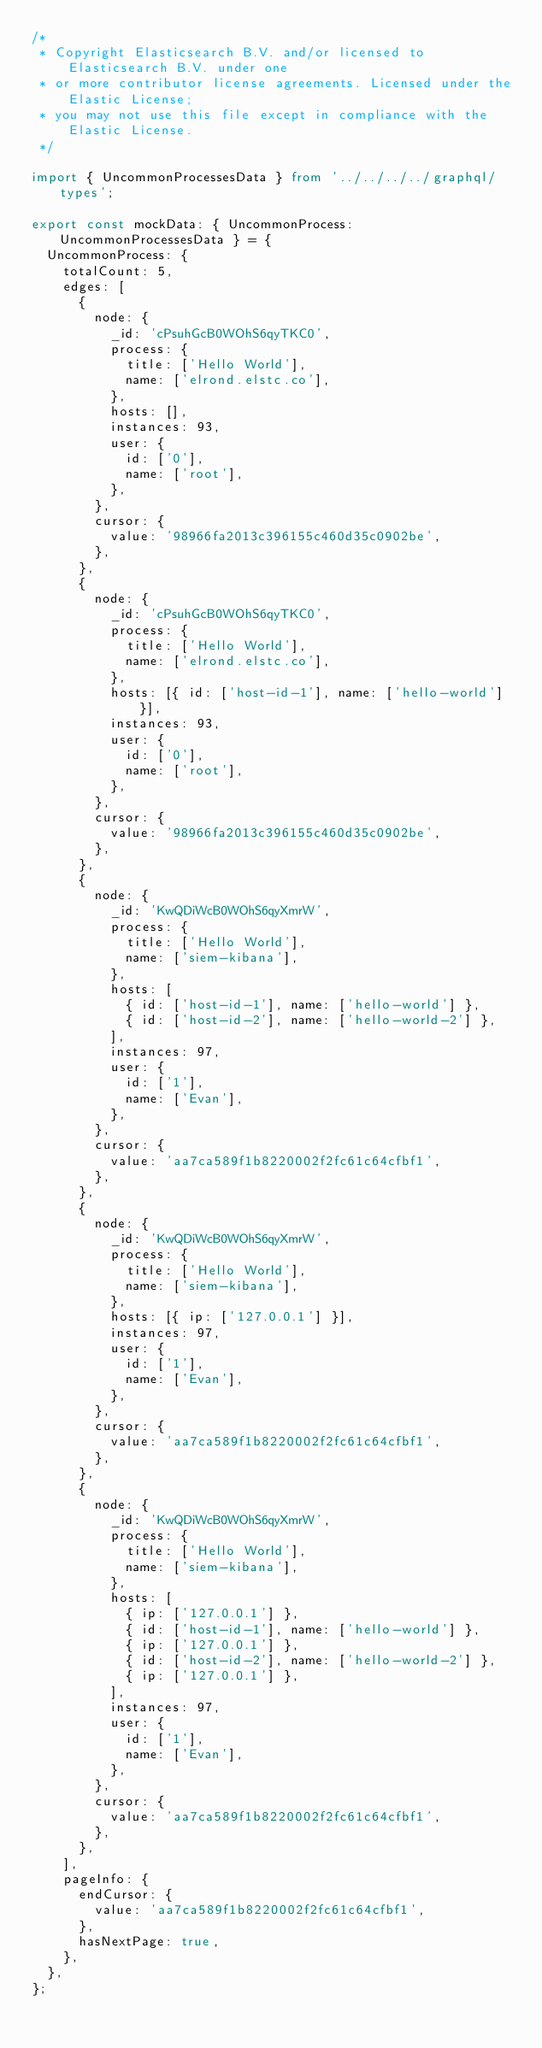Convert code to text. <code><loc_0><loc_0><loc_500><loc_500><_TypeScript_>/*
 * Copyright Elasticsearch B.V. and/or licensed to Elasticsearch B.V. under one
 * or more contributor license agreements. Licensed under the Elastic License;
 * you may not use this file except in compliance with the Elastic License.
 */

import { UncommonProcessesData } from '../../../../graphql/types';

export const mockData: { UncommonProcess: UncommonProcessesData } = {
  UncommonProcess: {
    totalCount: 5,
    edges: [
      {
        node: {
          _id: 'cPsuhGcB0WOhS6qyTKC0',
          process: {
            title: ['Hello World'],
            name: ['elrond.elstc.co'],
          },
          hosts: [],
          instances: 93,
          user: {
            id: ['0'],
            name: ['root'],
          },
        },
        cursor: {
          value: '98966fa2013c396155c460d35c0902be',
        },
      },
      {
        node: {
          _id: 'cPsuhGcB0WOhS6qyTKC0',
          process: {
            title: ['Hello World'],
            name: ['elrond.elstc.co'],
          },
          hosts: [{ id: ['host-id-1'], name: ['hello-world'] }],
          instances: 93,
          user: {
            id: ['0'],
            name: ['root'],
          },
        },
        cursor: {
          value: '98966fa2013c396155c460d35c0902be',
        },
      },
      {
        node: {
          _id: 'KwQDiWcB0WOhS6qyXmrW',
          process: {
            title: ['Hello World'],
            name: ['siem-kibana'],
          },
          hosts: [
            { id: ['host-id-1'], name: ['hello-world'] },
            { id: ['host-id-2'], name: ['hello-world-2'] },
          ],
          instances: 97,
          user: {
            id: ['1'],
            name: ['Evan'],
          },
        },
        cursor: {
          value: 'aa7ca589f1b8220002f2fc61c64cfbf1',
        },
      },
      {
        node: {
          _id: 'KwQDiWcB0WOhS6qyXmrW',
          process: {
            title: ['Hello World'],
            name: ['siem-kibana'],
          },
          hosts: [{ ip: ['127.0.0.1'] }],
          instances: 97,
          user: {
            id: ['1'],
            name: ['Evan'],
          },
        },
        cursor: {
          value: 'aa7ca589f1b8220002f2fc61c64cfbf1',
        },
      },
      {
        node: {
          _id: 'KwQDiWcB0WOhS6qyXmrW',
          process: {
            title: ['Hello World'],
            name: ['siem-kibana'],
          },
          hosts: [
            { ip: ['127.0.0.1'] },
            { id: ['host-id-1'], name: ['hello-world'] },
            { ip: ['127.0.0.1'] },
            { id: ['host-id-2'], name: ['hello-world-2'] },
            { ip: ['127.0.0.1'] },
          ],
          instances: 97,
          user: {
            id: ['1'],
            name: ['Evan'],
          },
        },
        cursor: {
          value: 'aa7ca589f1b8220002f2fc61c64cfbf1',
        },
      },
    ],
    pageInfo: {
      endCursor: {
        value: 'aa7ca589f1b8220002f2fc61c64cfbf1',
      },
      hasNextPage: true,
    },
  },
};
</code> 